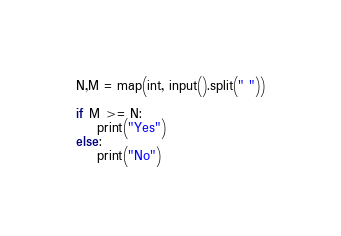<code> <loc_0><loc_0><loc_500><loc_500><_Python_>N,M = map(int, input().split(" "))

if M >= N:
    print("Yes")
else:
    print("No")</code> 